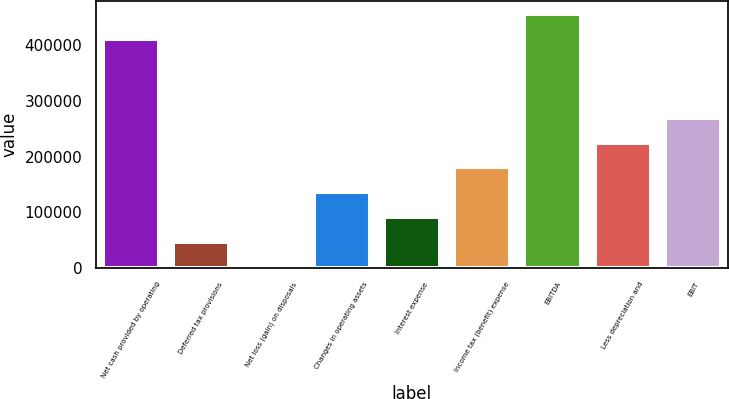Convert chart to OTSL. <chart><loc_0><loc_0><loc_500><loc_500><bar_chart><fcel>Net cash provided by operating<fcel>Deferred tax provisions<fcel>Net loss (gain) on disposals<fcel>Changes in operating assets<fcel>Interest expense<fcel>Income tax (benefit) expense<fcel>EBITDA<fcel>Less depreciation and<fcel>EBIT<nl><fcel>411646<fcel>46635<fcel>1980<fcel>135945<fcel>91290<fcel>180600<fcel>456301<fcel>225255<fcel>269910<nl></chart> 